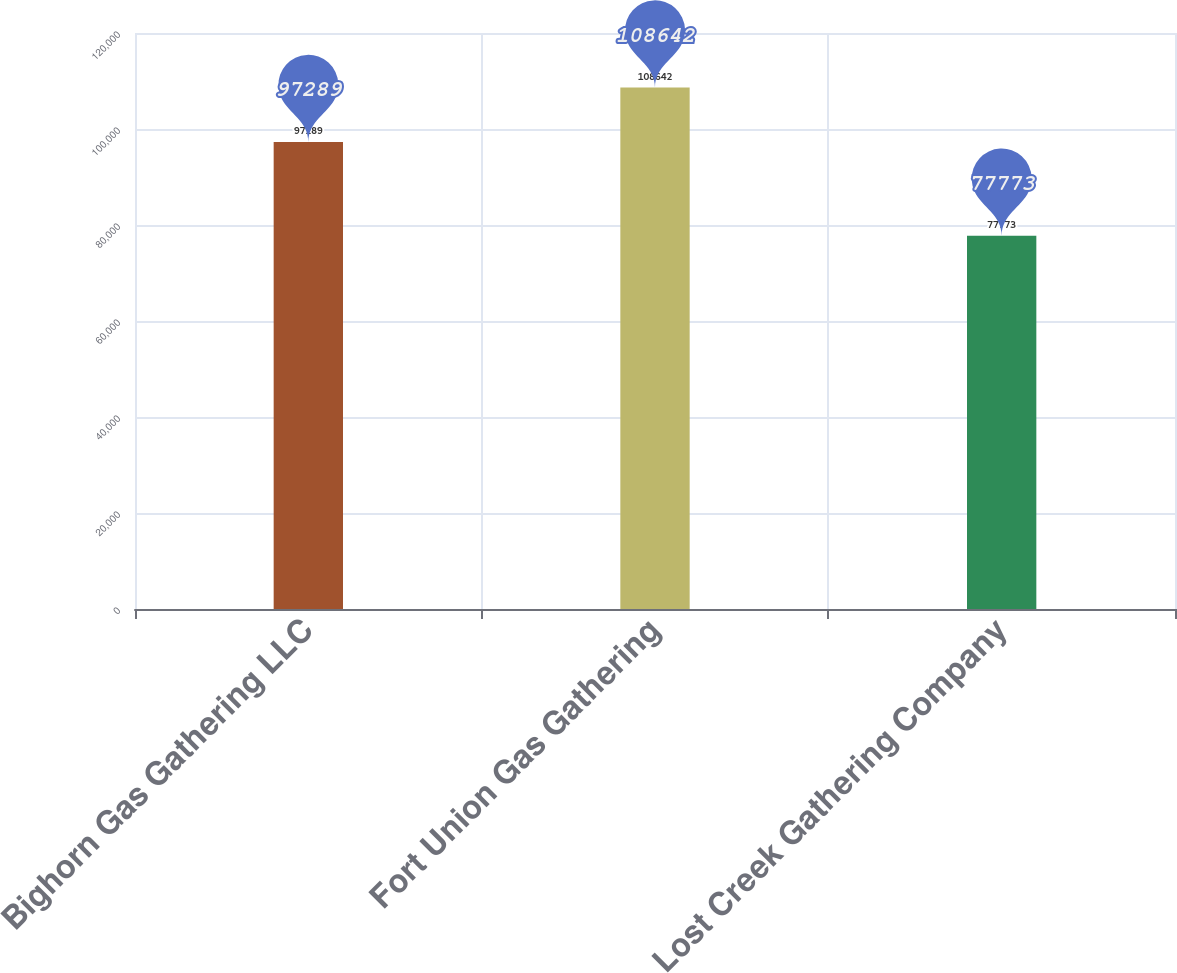Convert chart. <chart><loc_0><loc_0><loc_500><loc_500><bar_chart><fcel>Bighorn Gas Gathering LLC<fcel>Fort Union Gas Gathering<fcel>Lost Creek Gathering Company<nl><fcel>97289<fcel>108642<fcel>77773<nl></chart> 